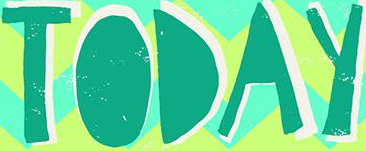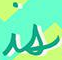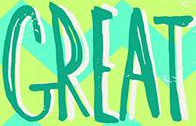Transcribe the words shown in these images in order, separated by a semicolon. TODAY; is; GREAT 